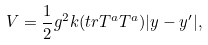<formula> <loc_0><loc_0><loc_500><loc_500>V = \frac { 1 } { 2 } g ^ { 2 } k ( t r T ^ { a } T ^ { a } ) | y - { y ^ { \prime } } | ,</formula> 